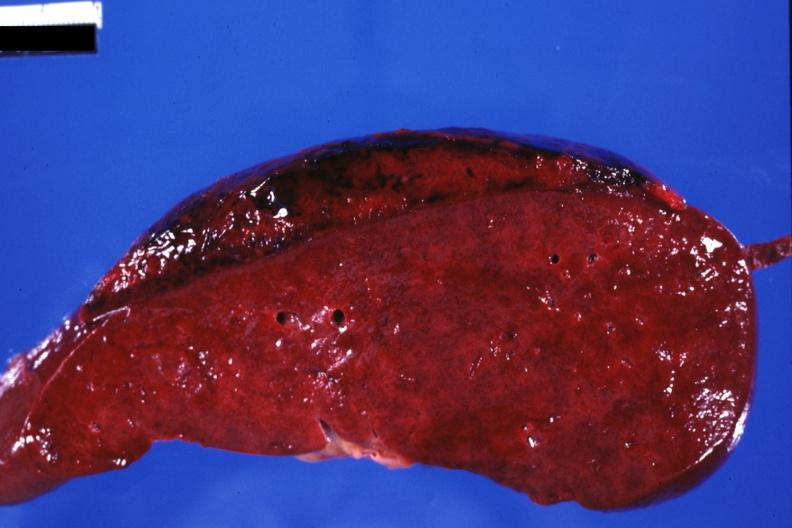what is present?
Answer the question using a single word or phrase. Subcapsular hematoma 